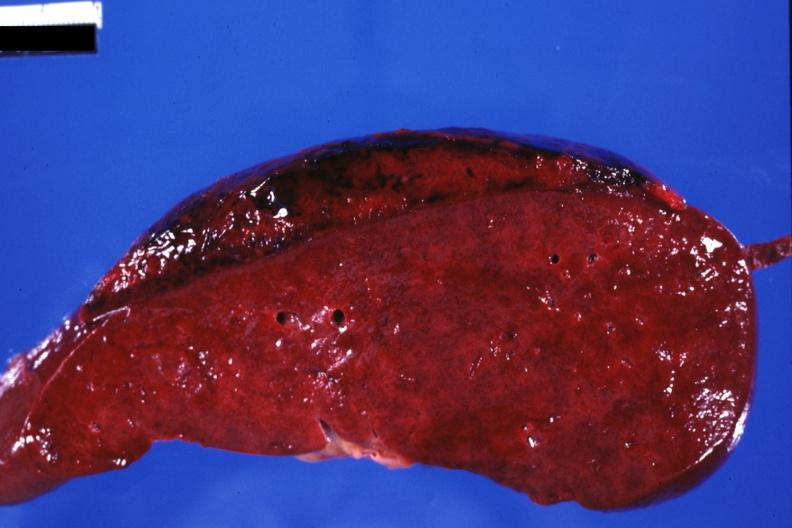what is present?
Answer the question using a single word or phrase. Subcapsular hematoma 